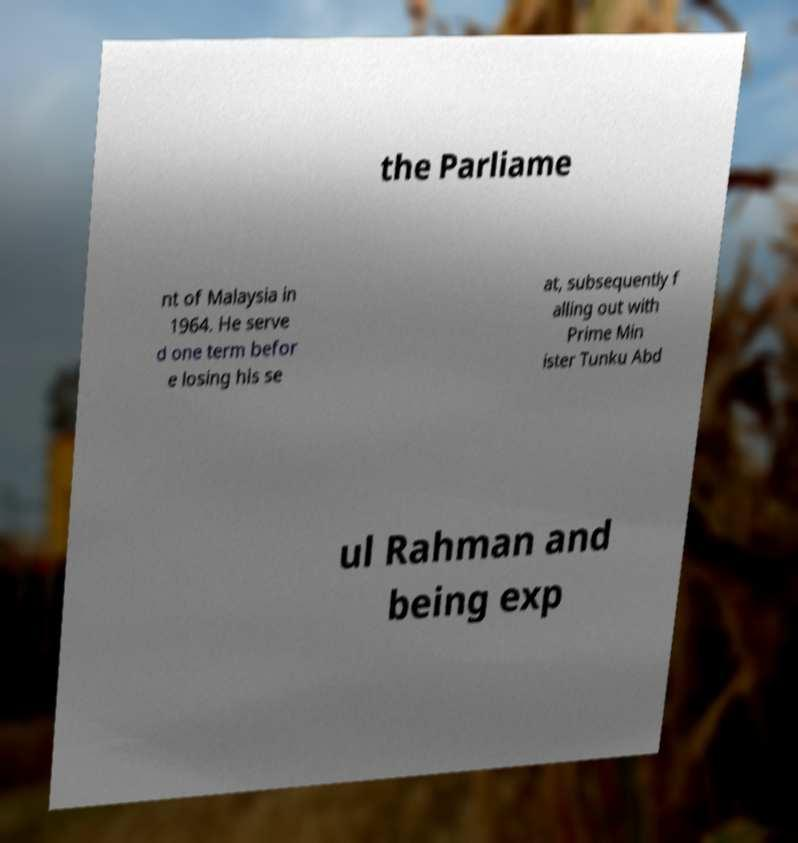Please read and relay the text visible in this image. What does it say? the Parliame nt of Malaysia in 1964. He serve d one term befor e losing his se at, subsequently f alling out with Prime Min ister Tunku Abd ul Rahman and being exp 